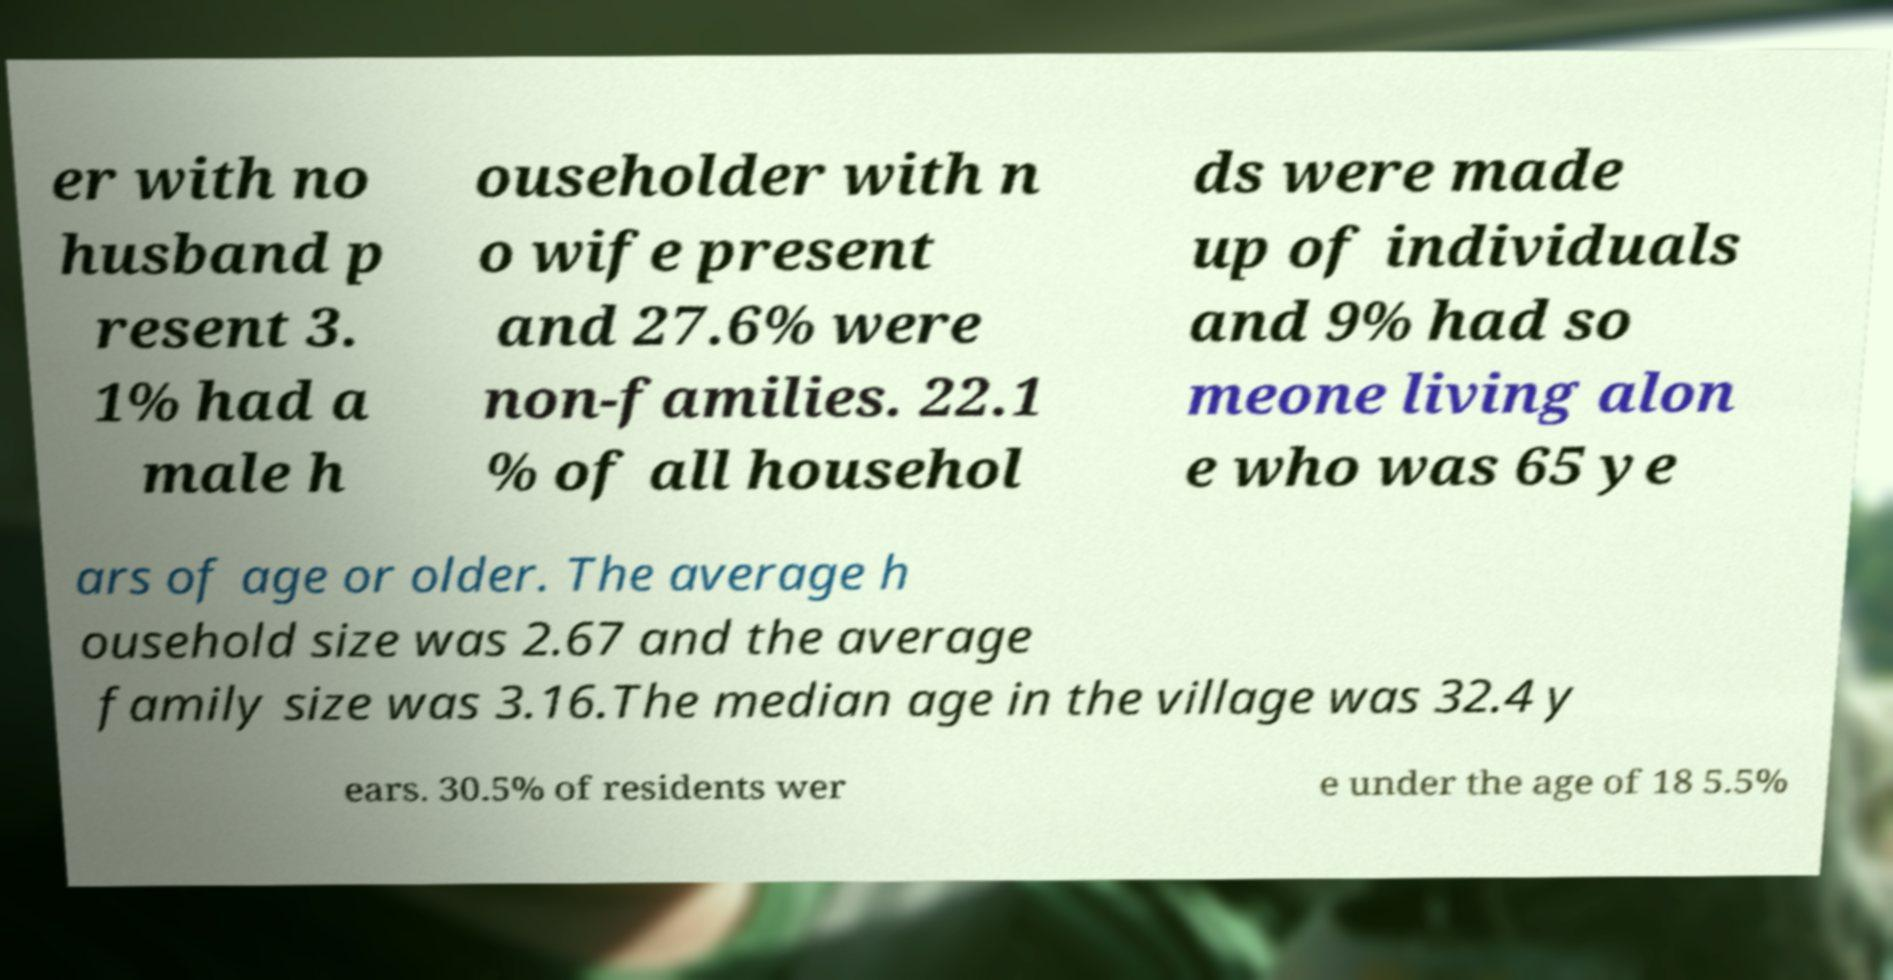Can you accurately transcribe the text from the provided image for me? er with no husband p resent 3. 1% had a male h ouseholder with n o wife present and 27.6% were non-families. 22.1 % of all househol ds were made up of individuals and 9% had so meone living alon e who was 65 ye ars of age or older. The average h ousehold size was 2.67 and the average family size was 3.16.The median age in the village was 32.4 y ears. 30.5% of residents wer e under the age of 18 5.5% 